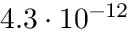Convert formula to latex. <formula><loc_0><loc_0><loc_500><loc_500>4 . 3 \cdot 1 0 ^ { - 1 2 }</formula> 